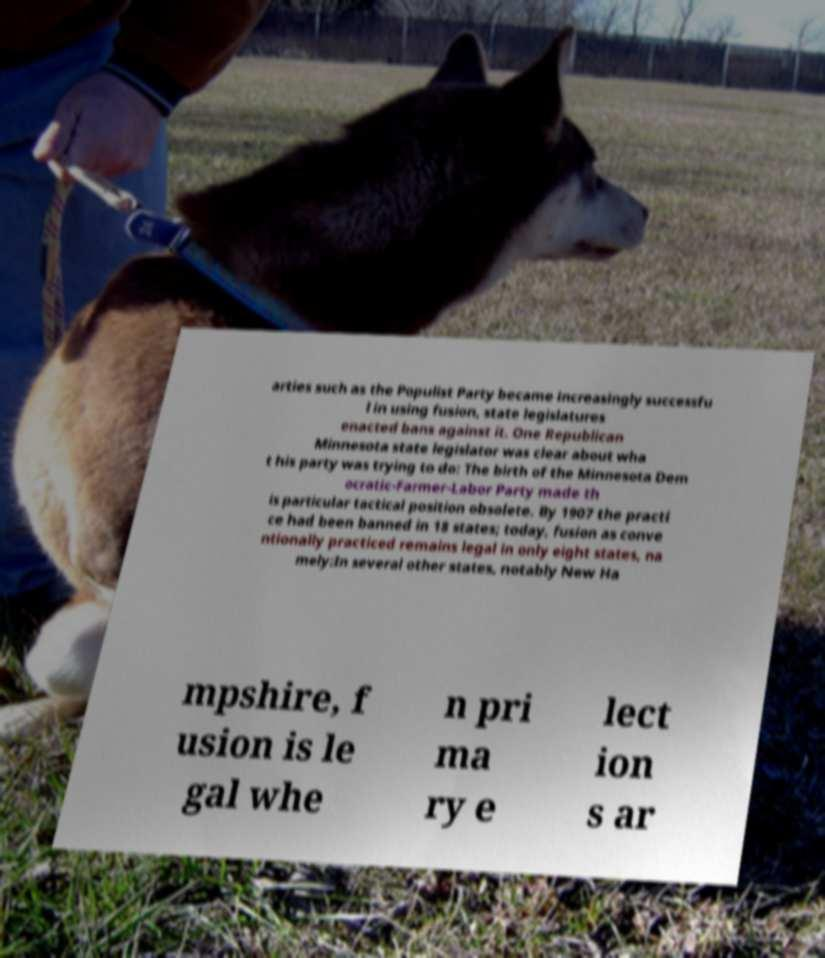Can you accurately transcribe the text from the provided image for me? arties such as the Populist Party became increasingly successfu l in using fusion, state legislatures enacted bans against it. One Republican Minnesota state legislator was clear about wha t his party was trying to do: The birth of the Minnesota Dem ocratic-Farmer-Labor Party made th is particular tactical position obsolete. By 1907 the practi ce had been banned in 18 states; today, fusion as conve ntionally practiced remains legal in only eight states, na mely:In several other states, notably New Ha mpshire, f usion is le gal whe n pri ma ry e lect ion s ar 